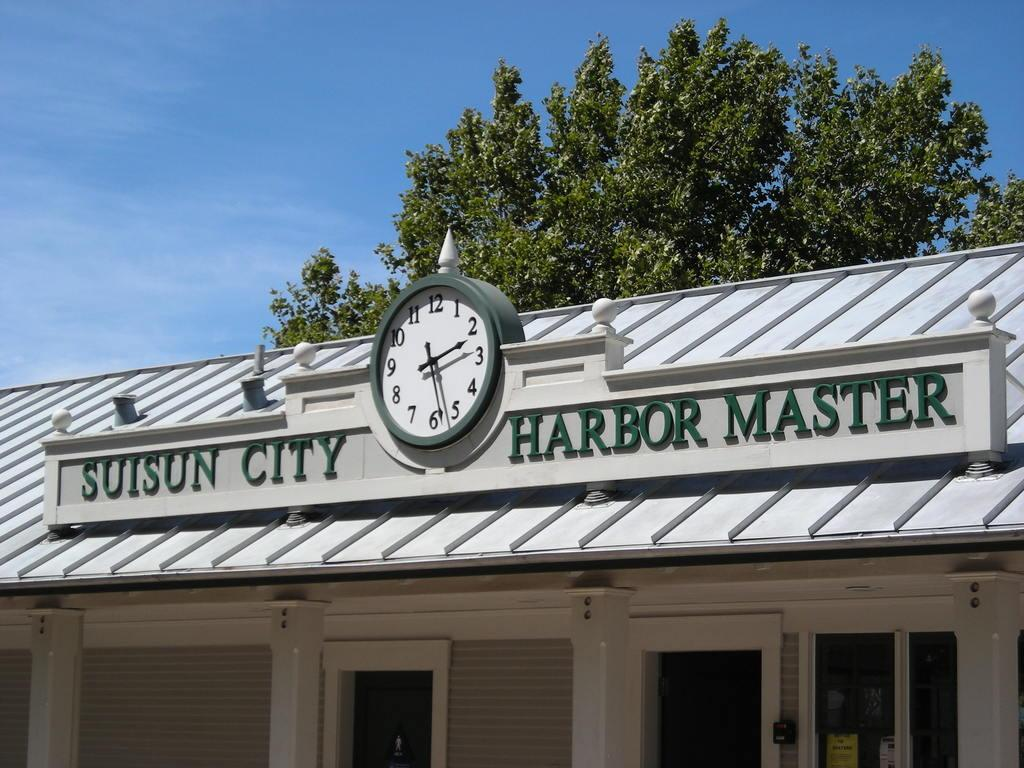<image>
Present a compact description of the photo's key features. A building labelled as the Suisun City Harbor Master. 